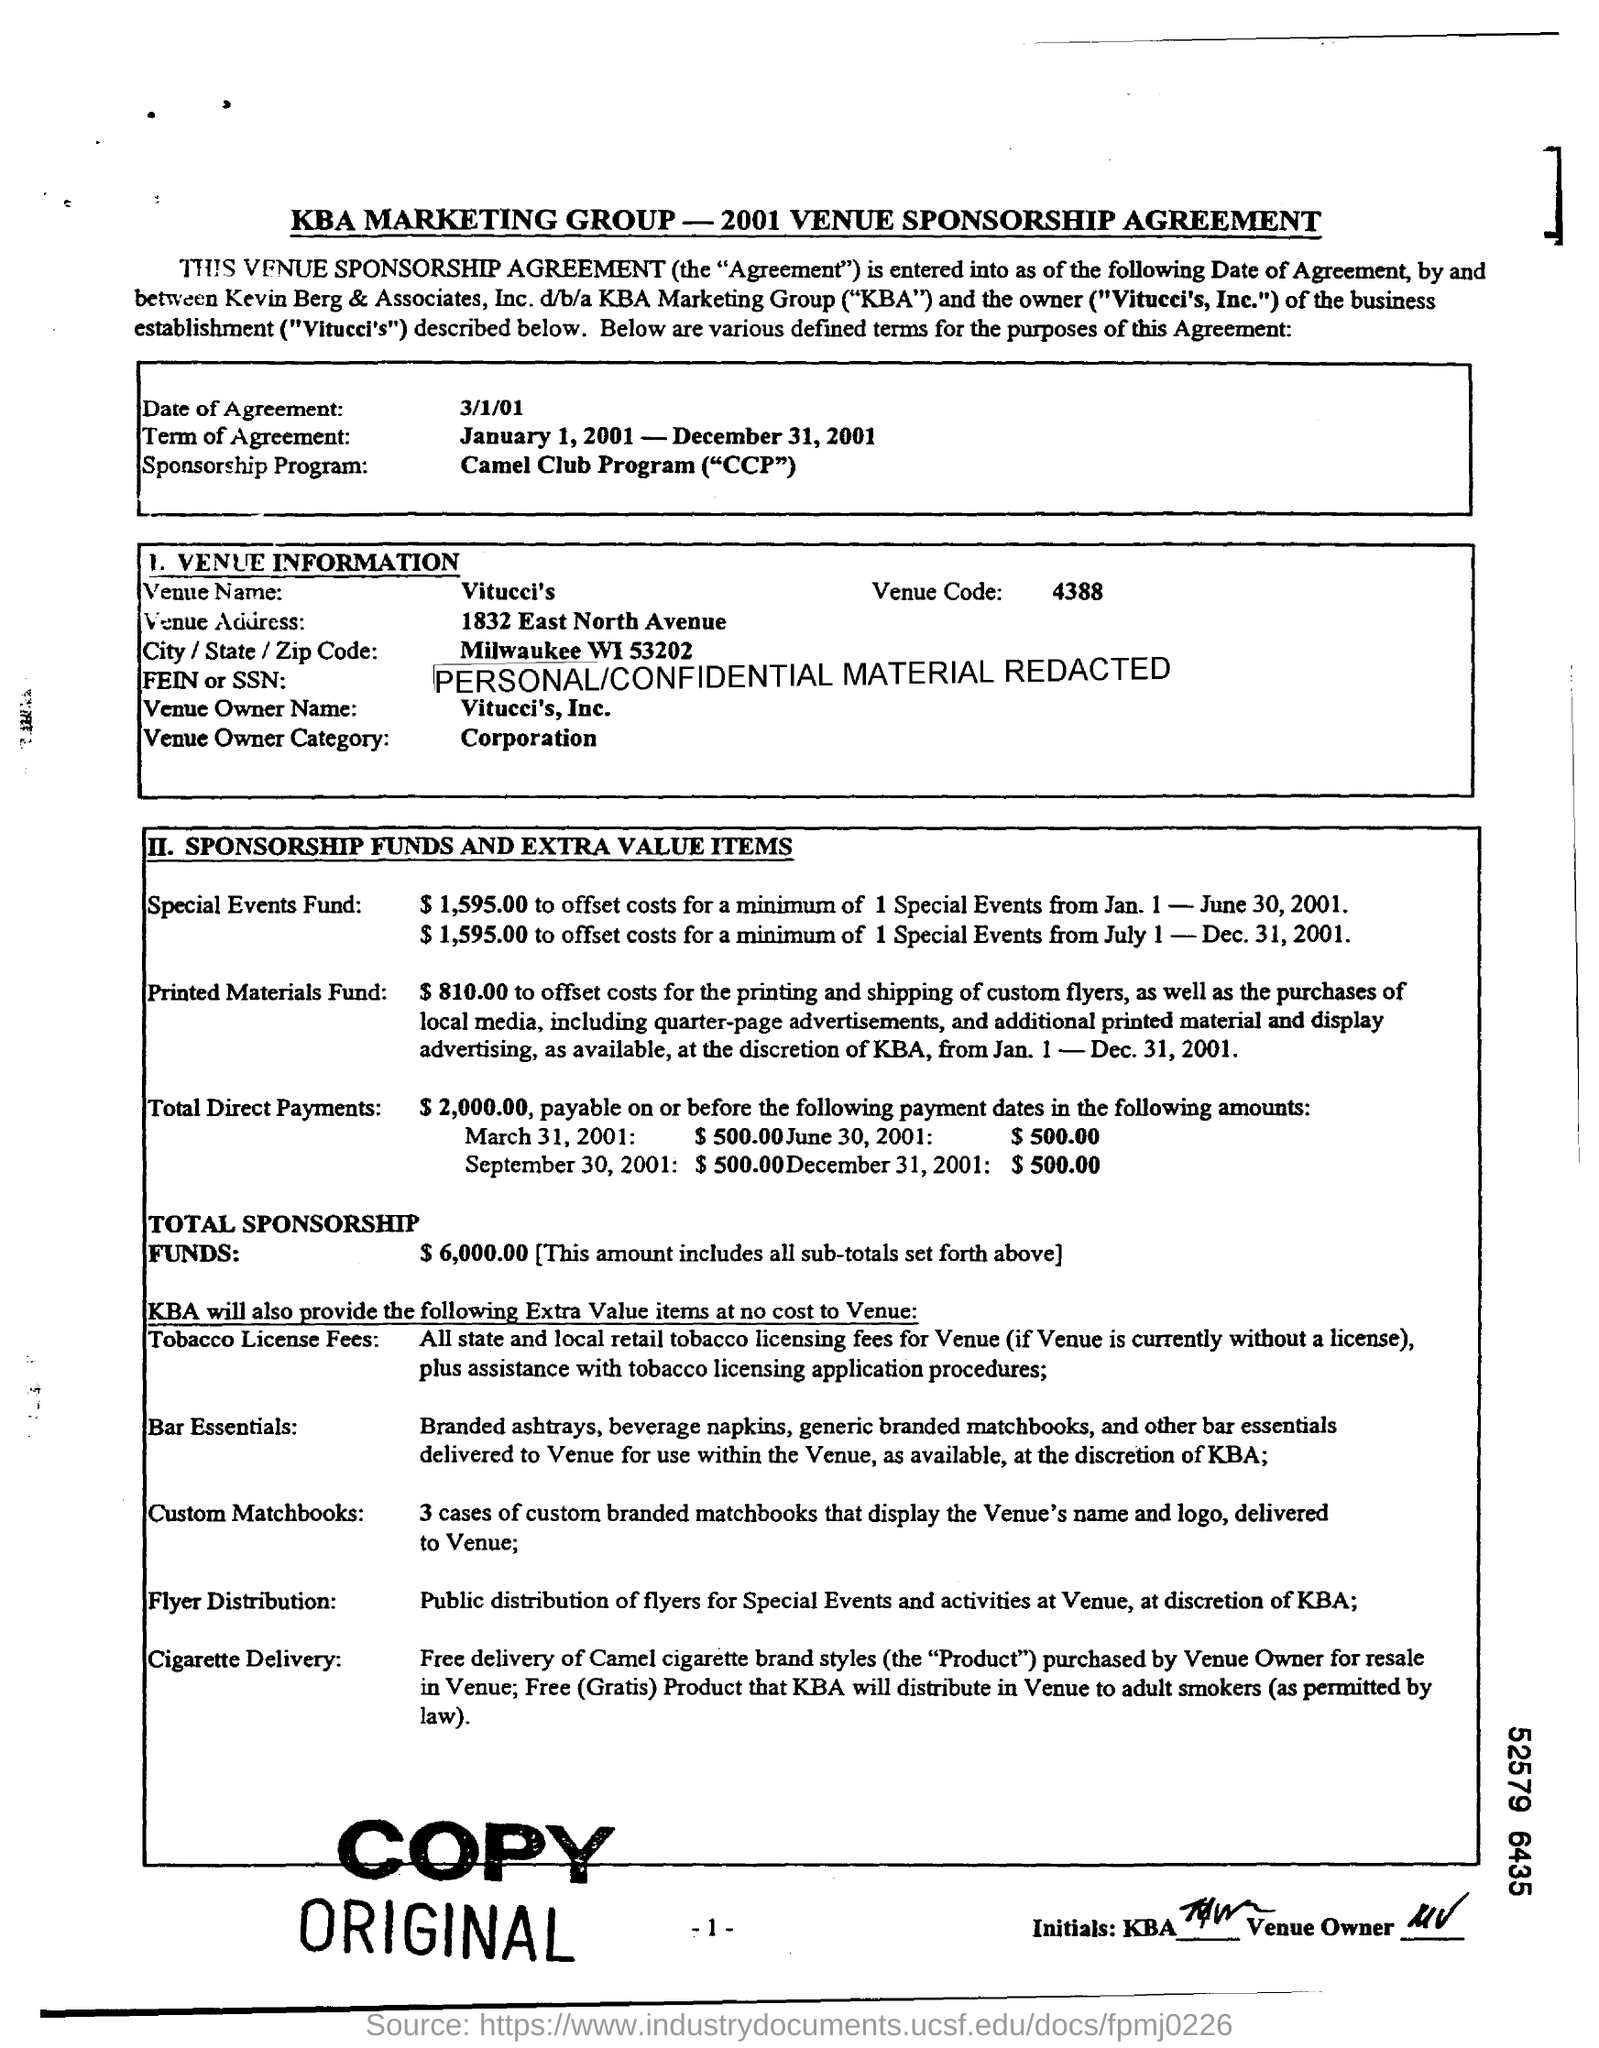What is the Date of Agreement?
Your answer should be very brief. 3/1/01. What is the Term of Agreement?
Keep it short and to the point. January 1, 2001 - December 31, 2001. What is the Venue Name?
Make the answer very short. Vitucci's. What is the Venue Code?
Make the answer very short. 4388. What is the Venue Owner Name?
Make the answer very short. Vitucci's, Inc. What is the Total Sponsorship Funds?
Provide a succinct answer. $ 6,000.00. 